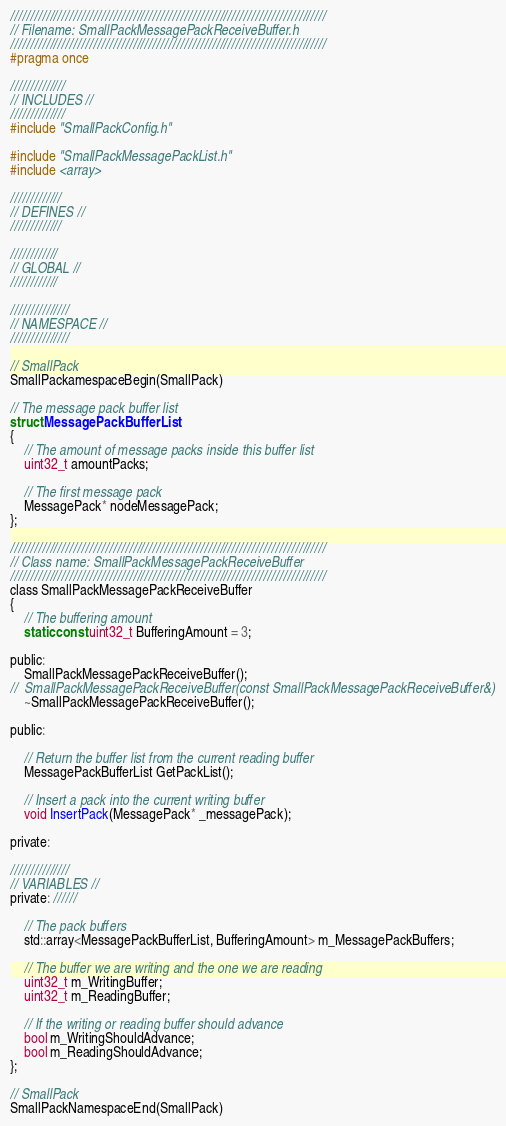Convert code to text. <code><loc_0><loc_0><loc_500><loc_500><_C_>////////////////////////////////////////////////////////////////////////////////
// Filename: SmallPackMessagePackReceiveBuffer.h
////////////////////////////////////////////////////////////////////////////////
#pragma once

//////////////
// INCLUDES //
//////////////
#include "SmallPackConfig.h"

#include "SmallPackMessagePackList.h"
#include <array>

/////////////
// DEFINES //
/////////////

////////////
// GLOBAL //
////////////

///////////////
// NAMESPACE //
///////////////

// SmallPack
SmallPackamespaceBegin(SmallPack)

// The message pack buffer list
struct MessagePackBufferList
{
	// The amount of message packs inside this buffer list
	uint32_t amountPacks;

	// The first message pack
	MessagePack* nodeMessagePack;
};

////////////////////////////////////////////////////////////////////////////////
// Class name: SmallPackMessagePackReceiveBuffer
////////////////////////////////////////////////////////////////////////////////
class SmallPackMessagePackReceiveBuffer
{
	// The buffering amount
	static const uint32_t BufferingAmount = 3;

public:
	SmallPackMessagePackReceiveBuffer();
//	SmallPackMessagePackReceiveBuffer(const SmallPackMessagePackReceiveBuffer&)
	~SmallPackMessagePackReceiveBuffer();

public:

	// Return the buffer list from the current reading buffer
	MessagePackBufferList GetPackList();

	// Insert a pack into the current writing buffer
	void InsertPack(MessagePack* _messagePack);

private:

///////////////
// VARIABLES //
private: //////

	// The pack buffers
	std::array<MessagePackBufferList, BufferingAmount> m_MessagePackBuffers;

	// The buffer we are writing and the one we are reading
	uint32_t m_WritingBuffer;
	uint32_t m_ReadingBuffer;

	// If the writing or reading buffer should advance
	bool m_WritingShouldAdvance;
	bool m_ReadingShouldAdvance;
};

// SmallPack
SmallPackNamespaceEnd(SmallPack)</code> 